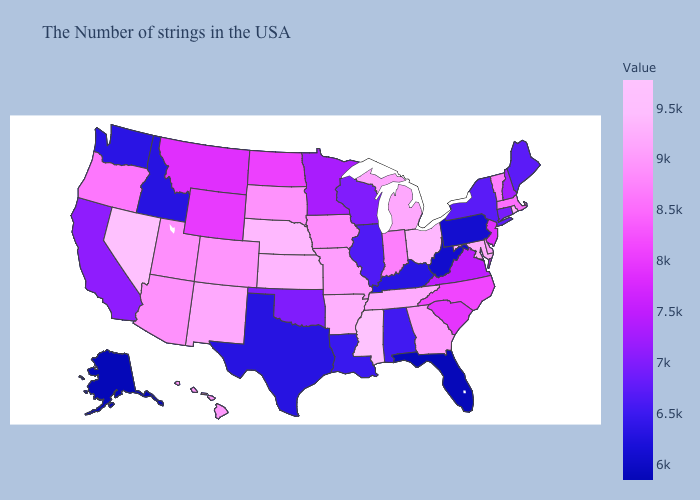Among the states that border Texas , which have the highest value?
Short answer required. Arkansas. Does Minnesota have the lowest value in the MidWest?
Be succinct. No. Does California have a higher value than Vermont?
Concise answer only. No. Among the states that border Alabama , which have the highest value?
Short answer required. Mississippi. Which states have the lowest value in the West?
Give a very brief answer. Alaska. Among the states that border Georgia , which have the lowest value?
Keep it brief. Florida. Among the states that border Indiana , which have the lowest value?
Quick response, please. Kentucky. 